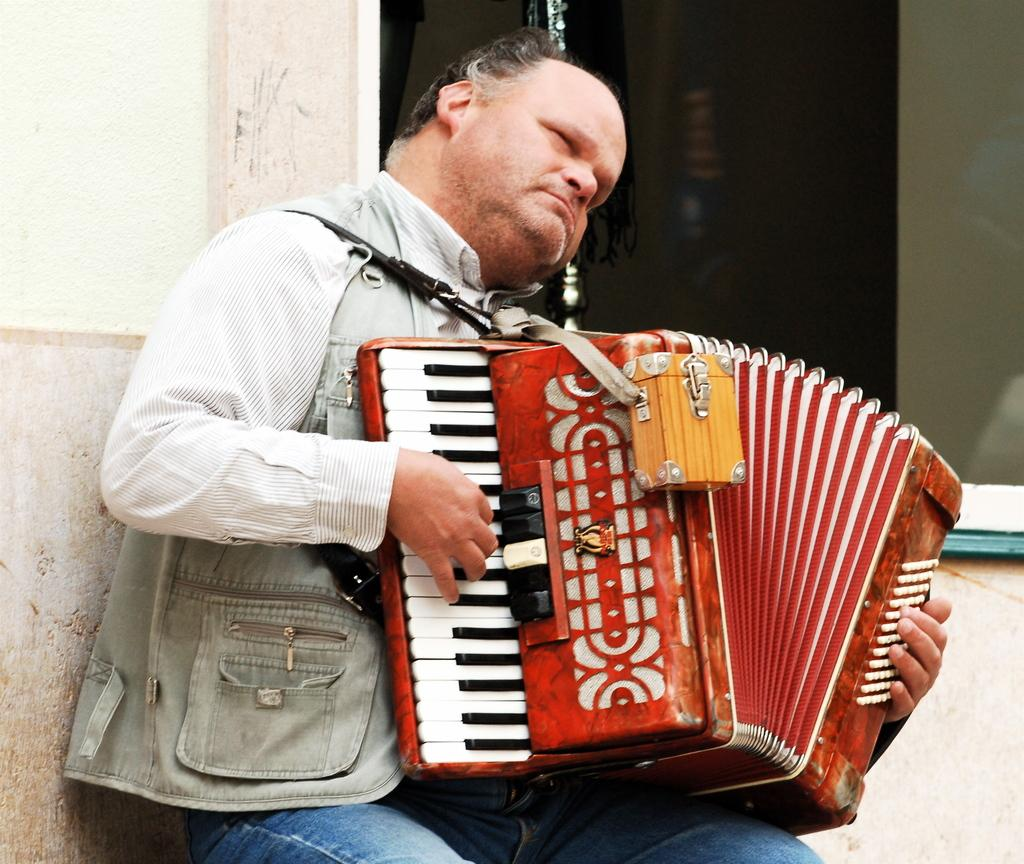What is the main subject of the image? The main subject of the image is a man. What is the man doing in the image? The man is playing a musical instrument in the image. What can be seen on the left side of the image? There is a wall on the left side of the image. What type of pickle is the man holding while playing the musical instrument? There is no pickle present in the image; the man is playing a musical instrument without any pickles. 